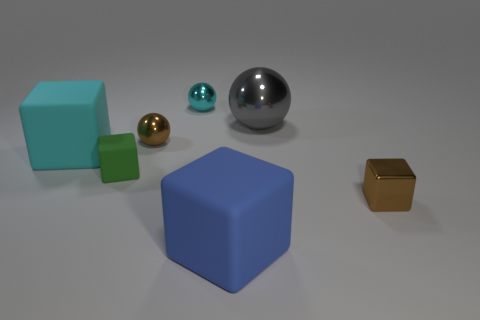What is the shape of the brown metal object behind the brown object right of the large rubber object that is in front of the green rubber thing?
Your response must be concise. Sphere. Is the number of gray shiny spheres right of the large cyan block the same as the number of red metal cylinders?
Keep it short and to the point. No. Do the cyan cube and the green rubber thing have the same size?
Your answer should be compact. No. How many metallic objects are gray objects or small gray cubes?
Give a very brief answer. 1. There is a cyan object that is the same size as the green object; what is it made of?
Your response must be concise. Metal. How many other things are there of the same material as the large gray object?
Provide a succinct answer. 3. Are there fewer matte things on the right side of the large cyan object than cubes?
Your response must be concise. Yes. Is the shape of the small cyan thing the same as the large cyan rubber thing?
Your answer should be very brief. No. There is a brown metallic object behind the large matte block that is behind the brown cube right of the blue rubber block; what is its size?
Give a very brief answer. Small. What material is the large cyan object that is the same shape as the tiny green rubber thing?
Your answer should be very brief. Rubber. 